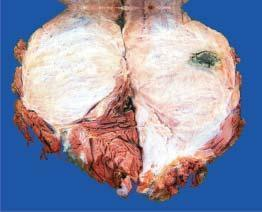what is somewhat circumscribed?
Answer the question using a single word or phrase. Lobulated tumour infiltrating the skeletal muscle 